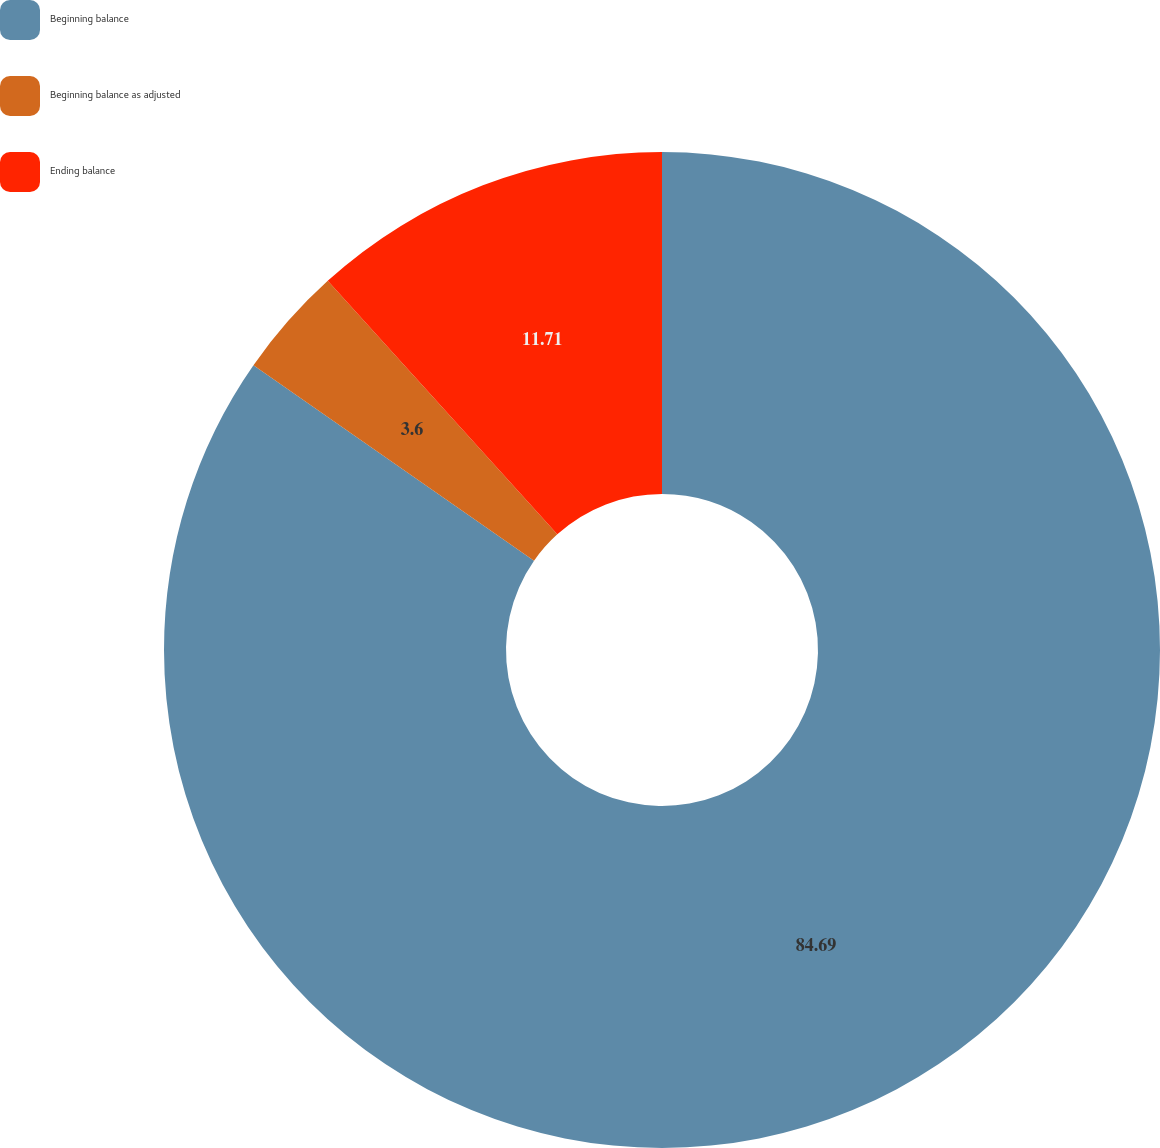Convert chart to OTSL. <chart><loc_0><loc_0><loc_500><loc_500><pie_chart><fcel>Beginning balance<fcel>Beginning balance as adjusted<fcel>Ending balance<nl><fcel>84.68%<fcel>3.6%<fcel>11.71%<nl></chart> 